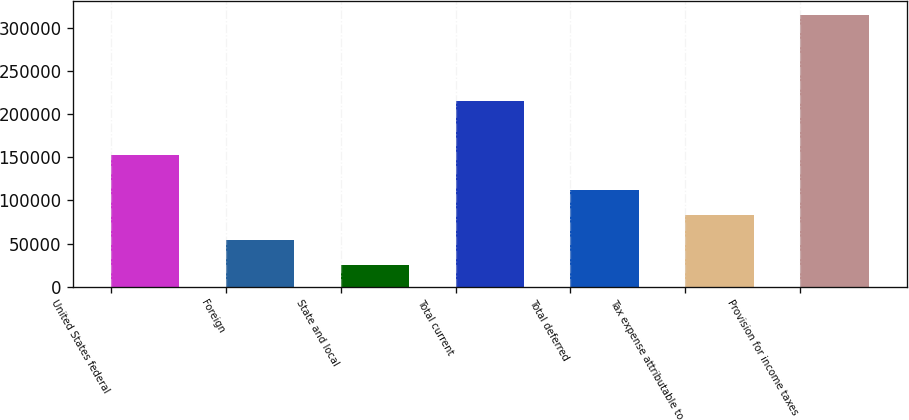<chart> <loc_0><loc_0><loc_500><loc_500><bar_chart><fcel>United States federal<fcel>Foreign<fcel>State and local<fcel>Total current<fcel>Total deferred<fcel>Tax expense attributable to<fcel>Provision for income taxes<nl><fcel>152840<fcel>54385.5<fcel>25427<fcel>215061<fcel>112302<fcel>83344<fcel>315012<nl></chart> 